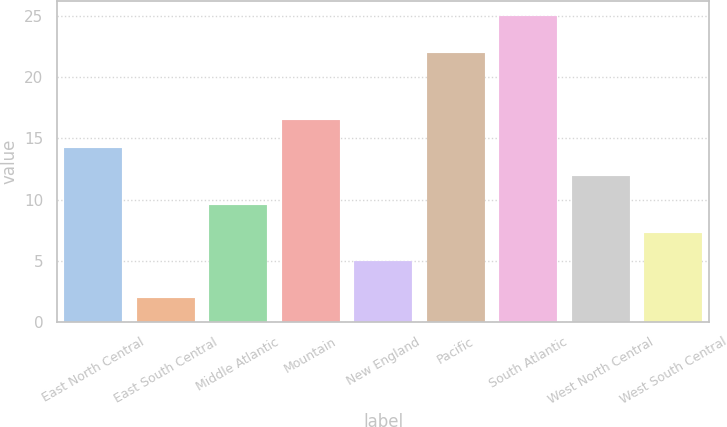Convert chart to OTSL. <chart><loc_0><loc_0><loc_500><loc_500><bar_chart><fcel>East North Central<fcel>East South Central<fcel>Middle Atlantic<fcel>Mountain<fcel>New England<fcel>Pacific<fcel>South Atlantic<fcel>West North Central<fcel>West South Central<nl><fcel>14.2<fcel>2<fcel>9.6<fcel>16.5<fcel>5<fcel>22<fcel>25<fcel>11.9<fcel>7.3<nl></chart> 